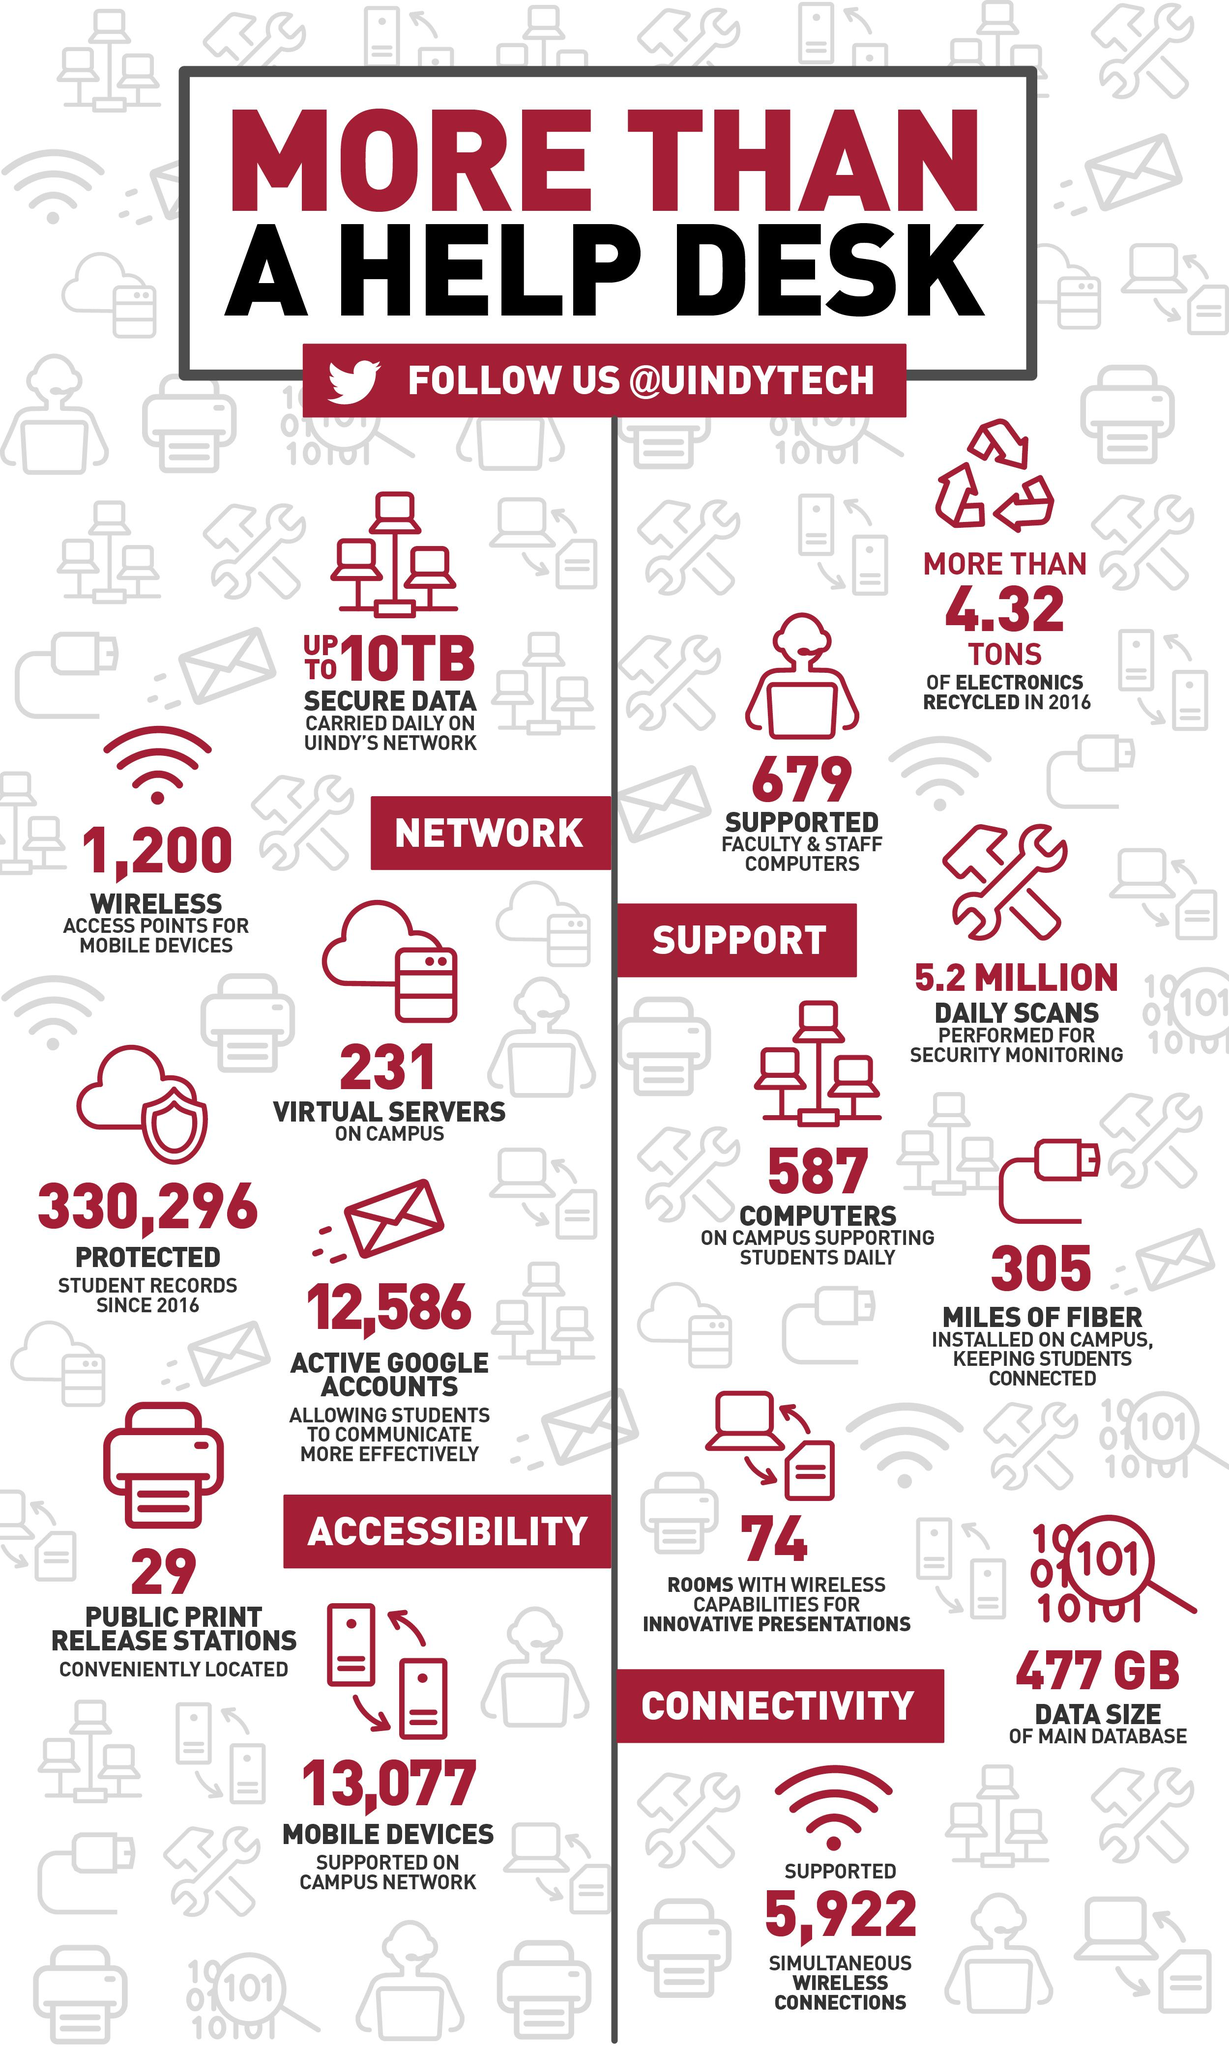List a handful of essential elements in this visual. The University of Indianapolis's network has carried out up to 10 terabytes of data daily. 